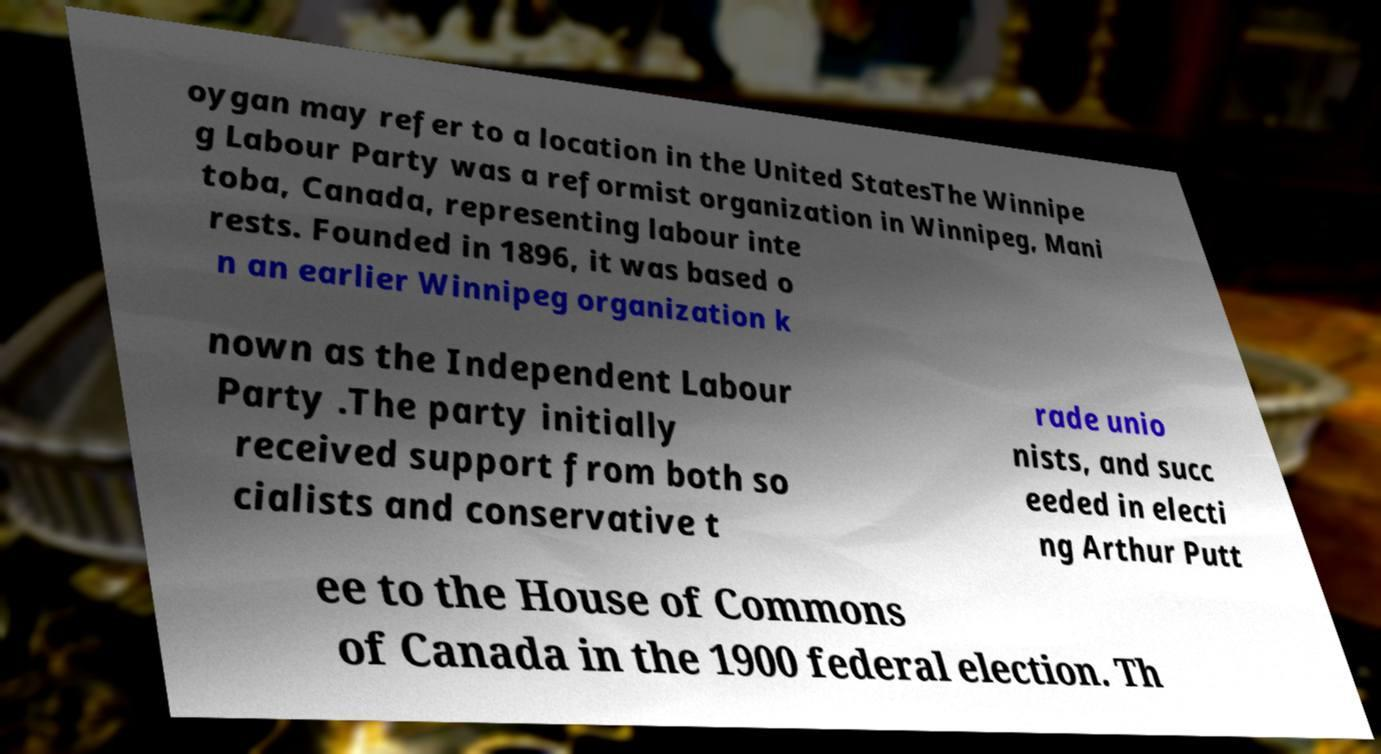Can you read and provide the text displayed in the image?This photo seems to have some interesting text. Can you extract and type it out for me? oygan may refer to a location in the United StatesThe Winnipe g Labour Party was a reformist organization in Winnipeg, Mani toba, Canada, representing labour inte rests. Founded in 1896, it was based o n an earlier Winnipeg organization k nown as the Independent Labour Party .The party initially received support from both so cialists and conservative t rade unio nists, and succ eeded in electi ng Arthur Putt ee to the House of Commons of Canada in the 1900 federal election. Th 